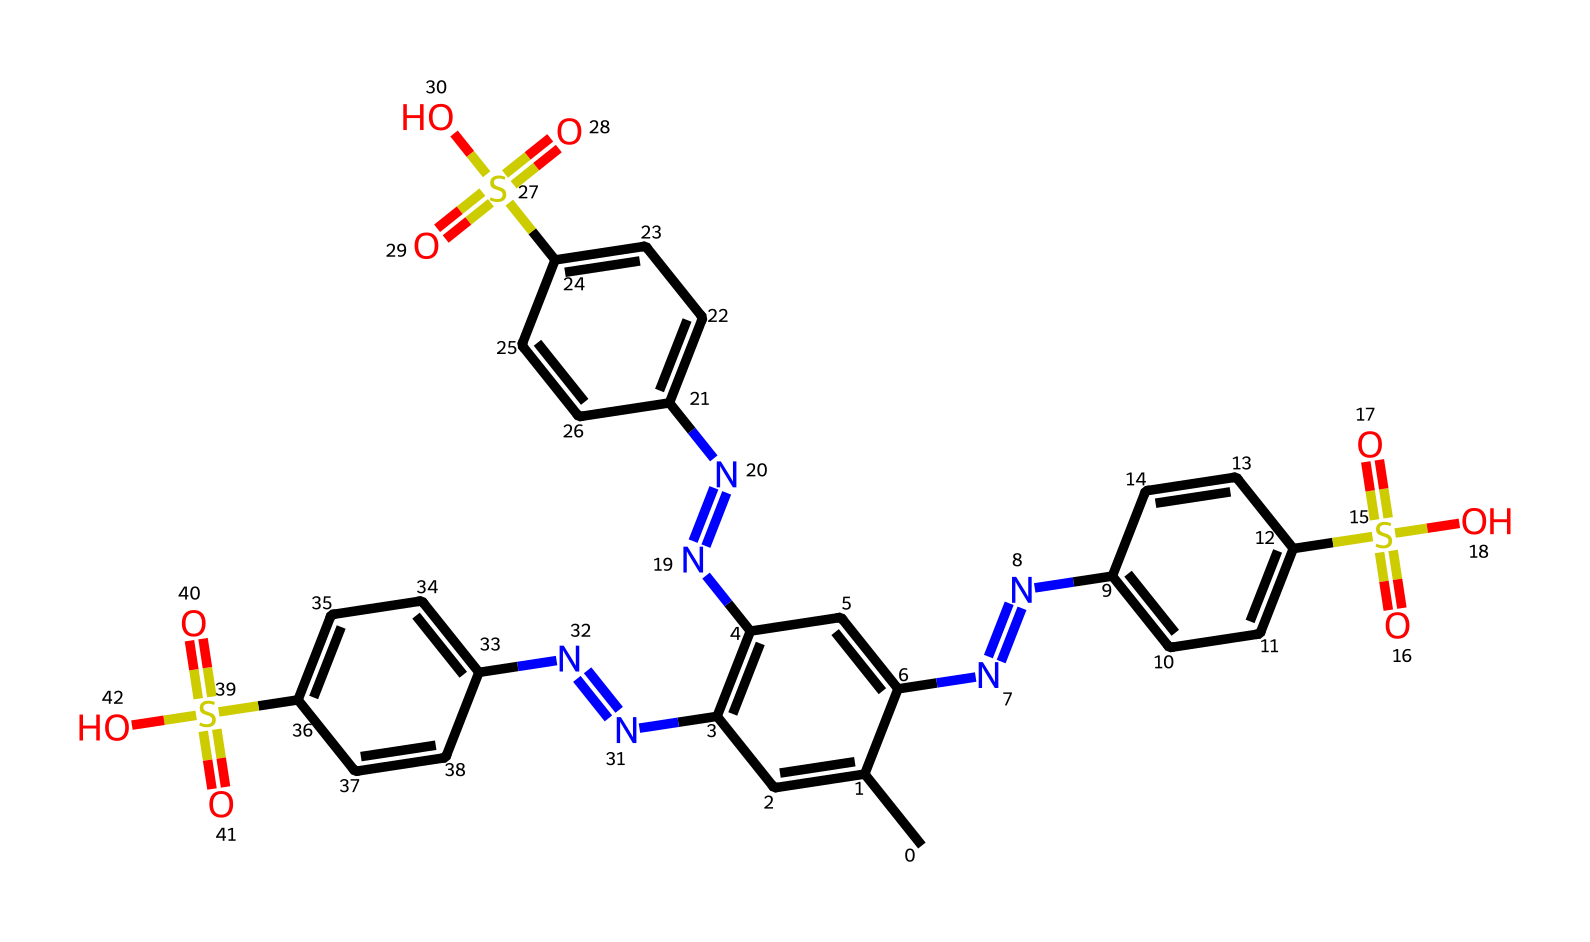What is the main functional group present in this structure? The presence of the sulfonic acid groups (–SO3H) indicates that the main functional group in the structure is a sulfonic acid.
Answer: sulfonic acid How many nitrogen atoms are in this compound? By analyzing the SMILES representation, there are four nitrogen atoms present, which can be counted by locating each ‘N’ present in the structure.
Answer: four Which colored pigment is likely represented in this chemical due to its structure? The presence of a sulfonic acid functional group and multiple aromatic rings suggests that this chemical is likely a type of azo dye, which corresponds with bright colors commonly seen in pride flag pigments.
Answer: azo dye What is the total number of aromatic rings in this molecule? The structure shows four interconnected aromatic rings, which can be confirmed by looking for the cyclic structures with alternating double bonds (denoted by ‘C=C’ patterns) in the SMILES.
Answer: four What type of chemical reaction would this compound likely undergo in a dyeing process? Given that the structure contains multiple sulfonic acid groups, it is likely to undergo sulfonation reactions, making it suitable for binding to fabrics in dyeing applications.
Answer: sulfonation 